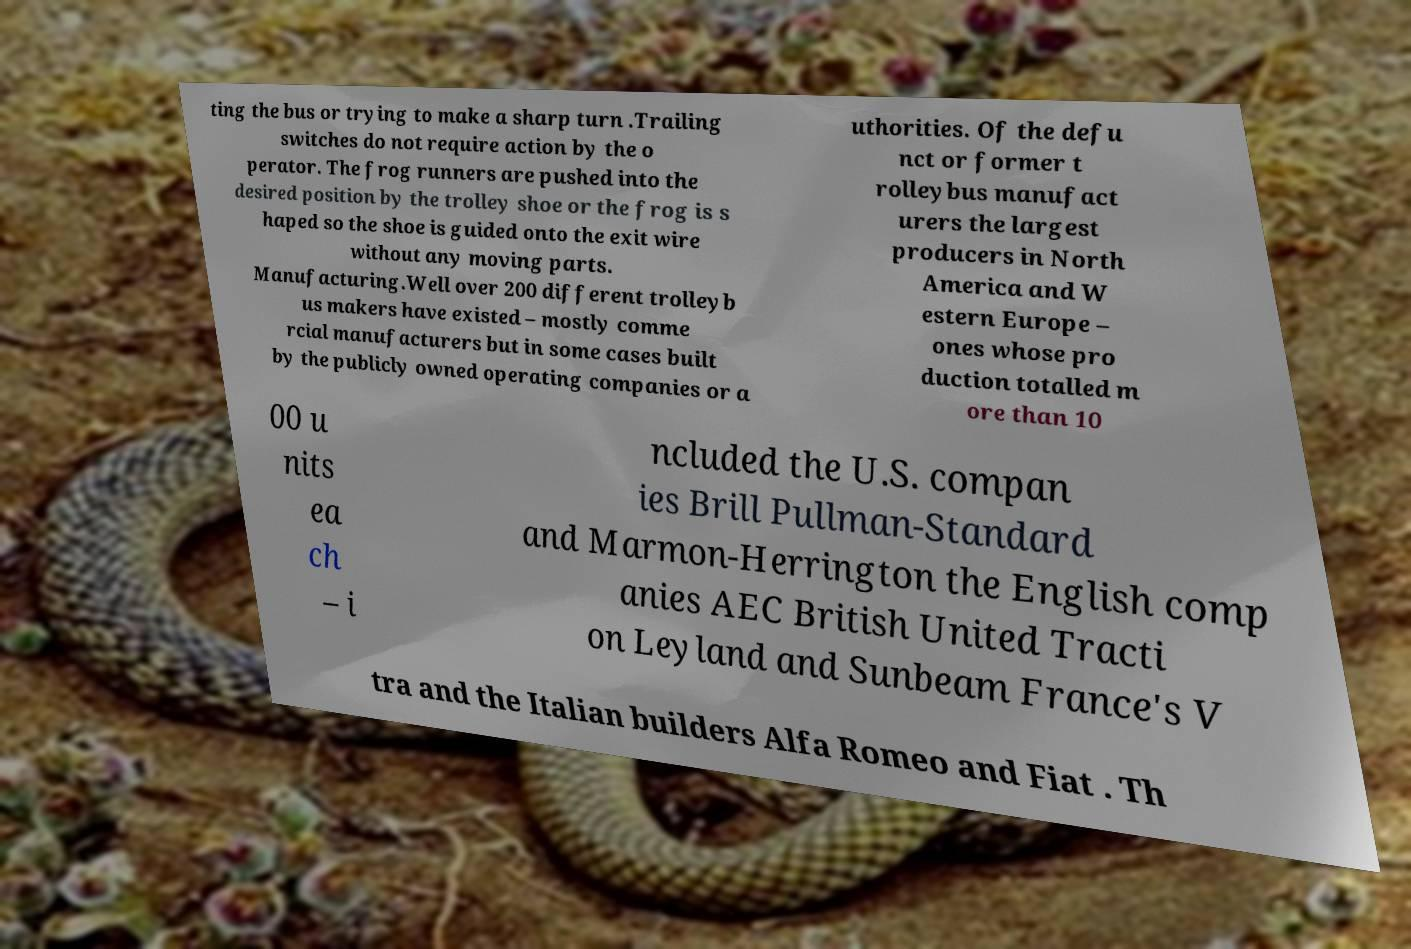There's text embedded in this image that I need extracted. Can you transcribe it verbatim? ting the bus or trying to make a sharp turn .Trailing switches do not require action by the o perator. The frog runners are pushed into the desired position by the trolley shoe or the frog is s haped so the shoe is guided onto the exit wire without any moving parts. Manufacturing.Well over 200 different trolleyb us makers have existed – mostly comme rcial manufacturers but in some cases built by the publicly owned operating companies or a uthorities. Of the defu nct or former t rolleybus manufact urers the largest producers in North America and W estern Europe – ones whose pro duction totalled m ore than 10 00 u nits ea ch – i ncluded the U.S. compan ies Brill Pullman-Standard and Marmon-Herrington the English comp anies AEC British United Tracti on Leyland and Sunbeam France's V tra and the Italian builders Alfa Romeo and Fiat . Th 